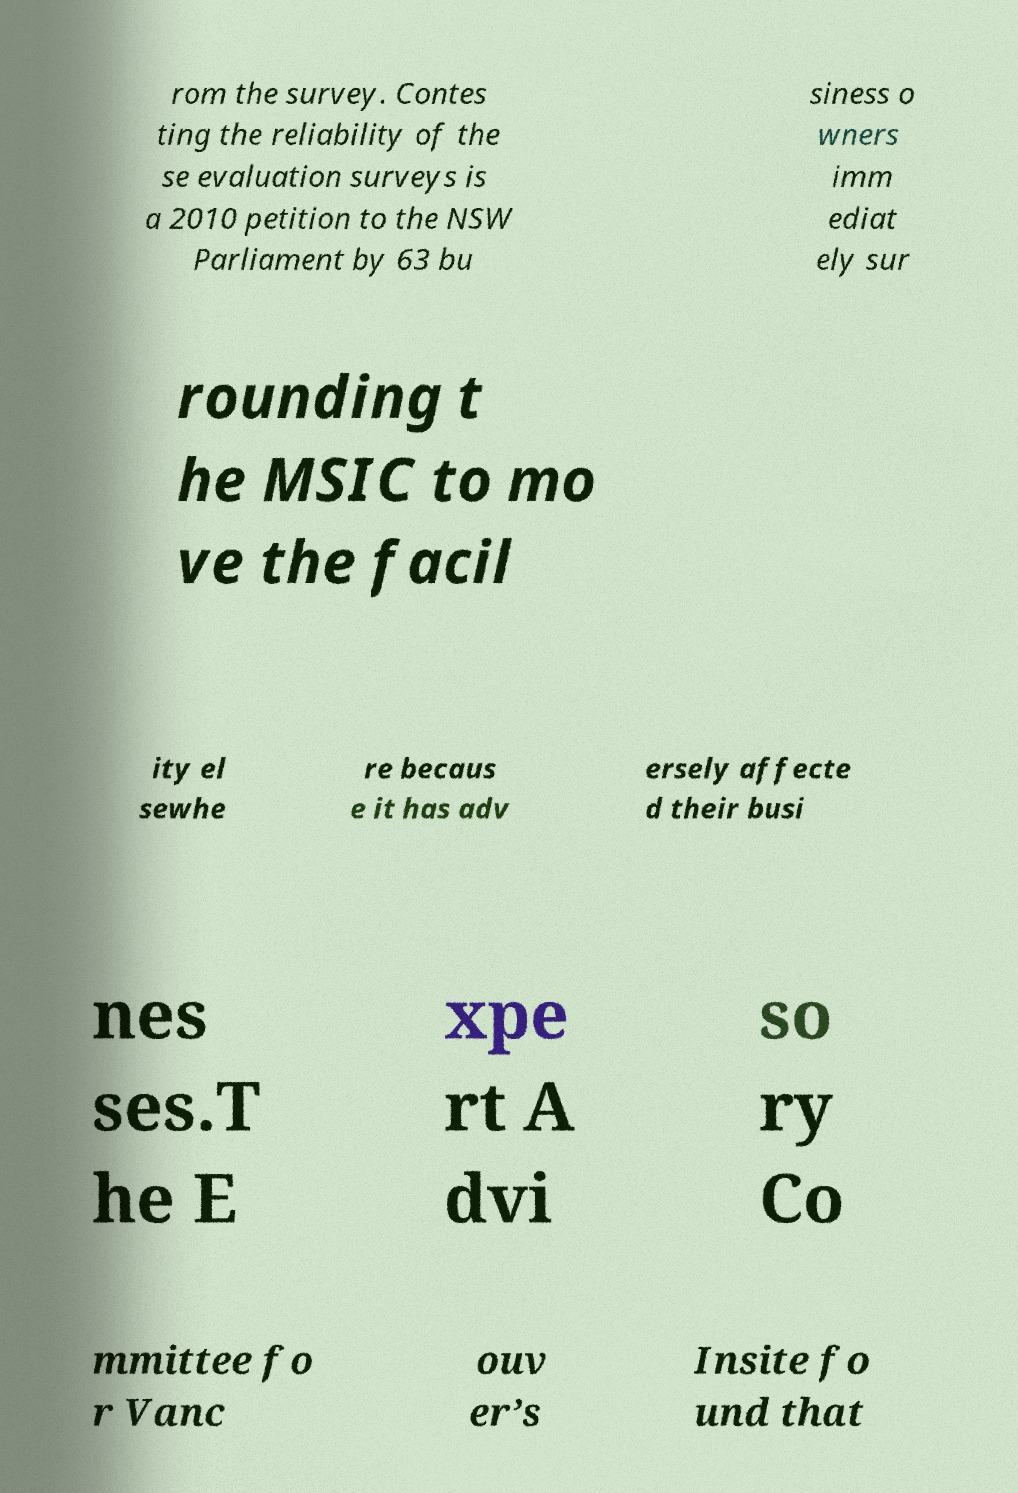I need the written content from this picture converted into text. Can you do that? rom the survey. Contes ting the reliability of the se evaluation surveys is a 2010 petition to the NSW Parliament by 63 bu siness o wners imm ediat ely sur rounding t he MSIC to mo ve the facil ity el sewhe re becaus e it has adv ersely affecte d their busi nes ses.T he E xpe rt A dvi so ry Co mmittee fo r Vanc ouv er’s Insite fo und that 